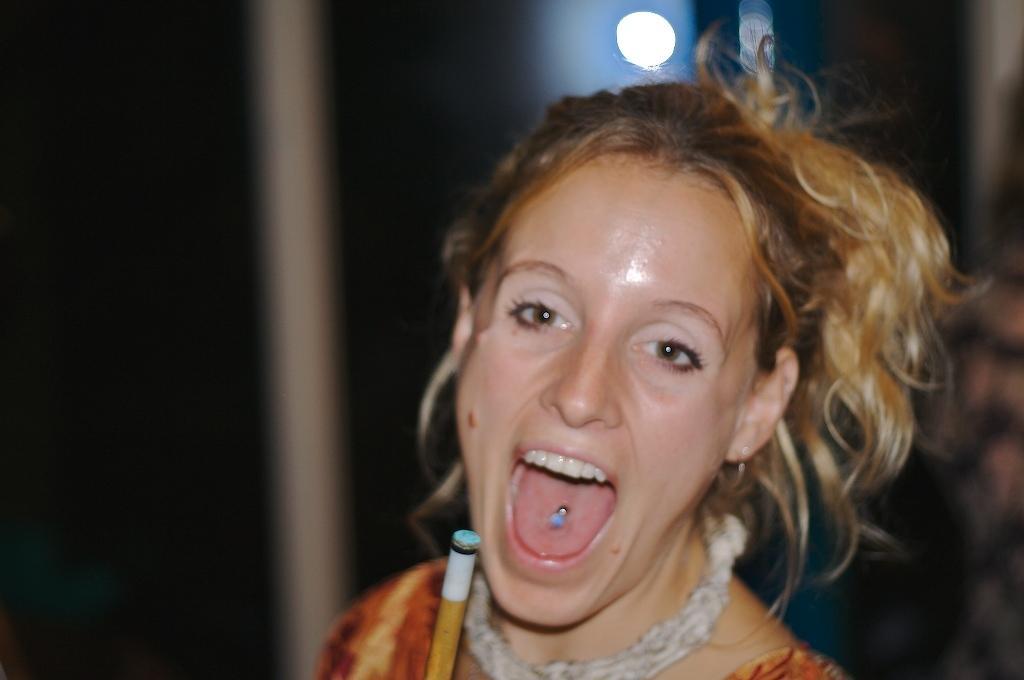Describe this image in one or two sentences. In the image a woman is standing and smiling. Background of the image is blur. 